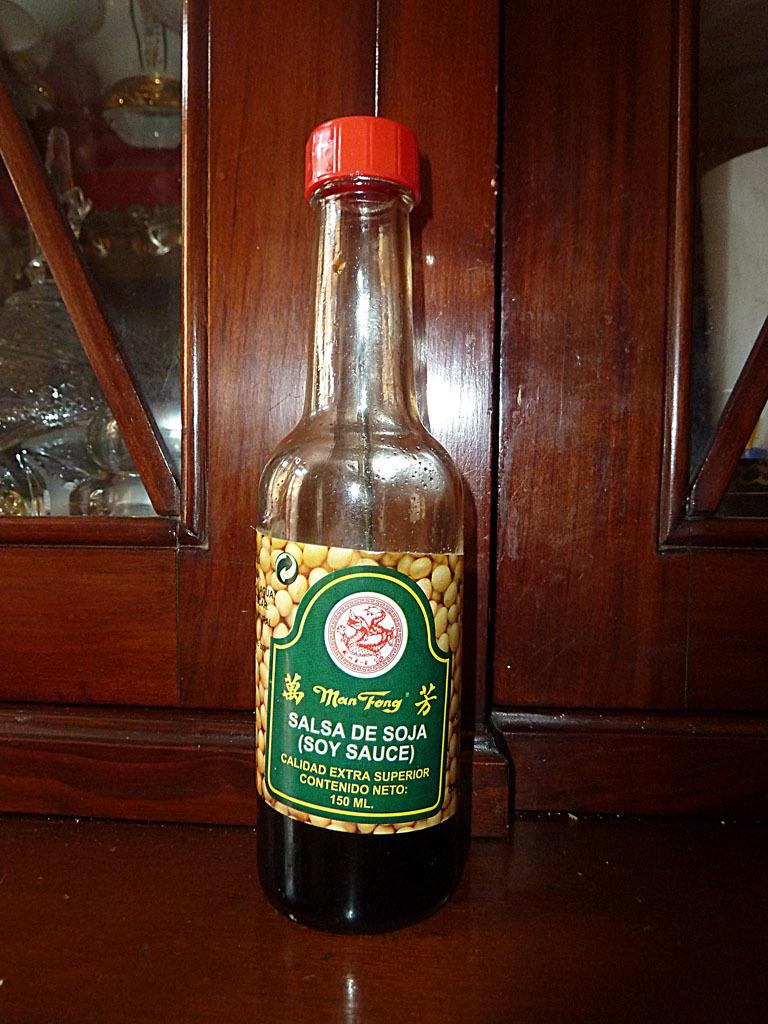What is on the table in the image? There is a soy sauce bottle on the table. What can be seen on the cap of the soy sauce bottle? The soy sauce bottle has a red color cap. What is located behind the soy sauce bottle? There is a cupboard behind the soy sauce bottle. What is inside the cupboard? There are items inside the cupboard. How many sheep are visible in the image? There are no sheep present in the image. What type of cloth is draped over the soy sauce bottle? There is no cloth draped over the soy sauce bottle in the image. 